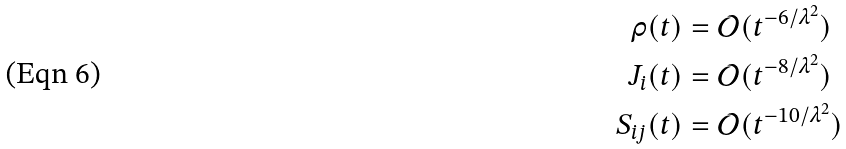<formula> <loc_0><loc_0><loc_500><loc_500>\rho ( t ) & = \mathcal { O } ( t ^ { - 6 / \lambda ^ { 2 } } ) \\ J _ { i } ( t ) & = \mathcal { O } ( t ^ { - 8 / \lambda ^ { 2 } } ) \\ S _ { i j } ( t ) & = \mathcal { O } ( t ^ { - 1 0 / \lambda ^ { 2 } } )</formula> 